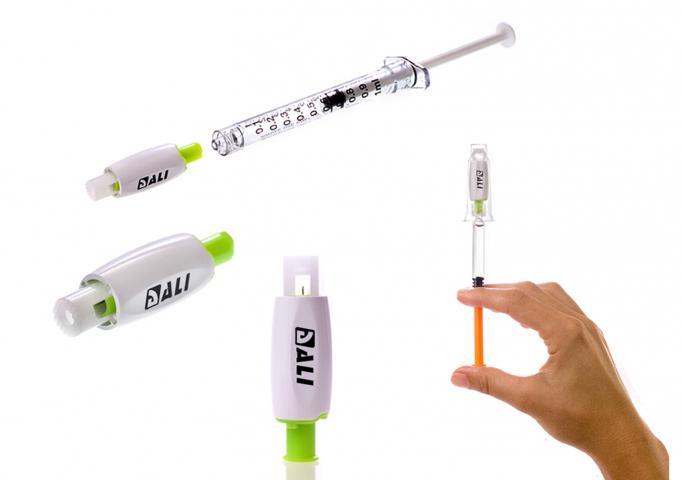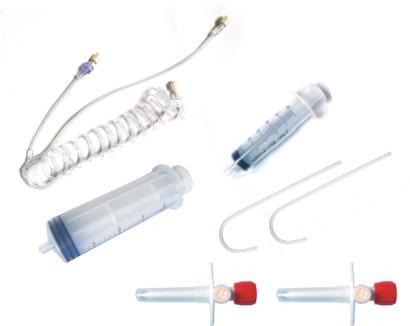The first image is the image on the left, the second image is the image on the right. Analyze the images presented: Is the assertion "There are three objects with plungers in the image on the right." valid? Answer yes or no. No. 